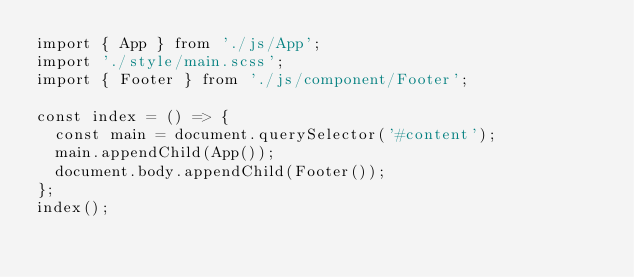<code> <loc_0><loc_0><loc_500><loc_500><_JavaScript_>import { App } from './js/App';
import './style/main.scss';
import { Footer } from './js/component/Footer';

const index = () => {
  const main = document.querySelector('#content');
  main.appendChild(App());
  document.body.appendChild(Footer());
};
index();</code> 